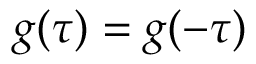Convert formula to latex. <formula><loc_0><loc_0><loc_500><loc_500>g ( \tau ) = g ( - \tau )</formula> 